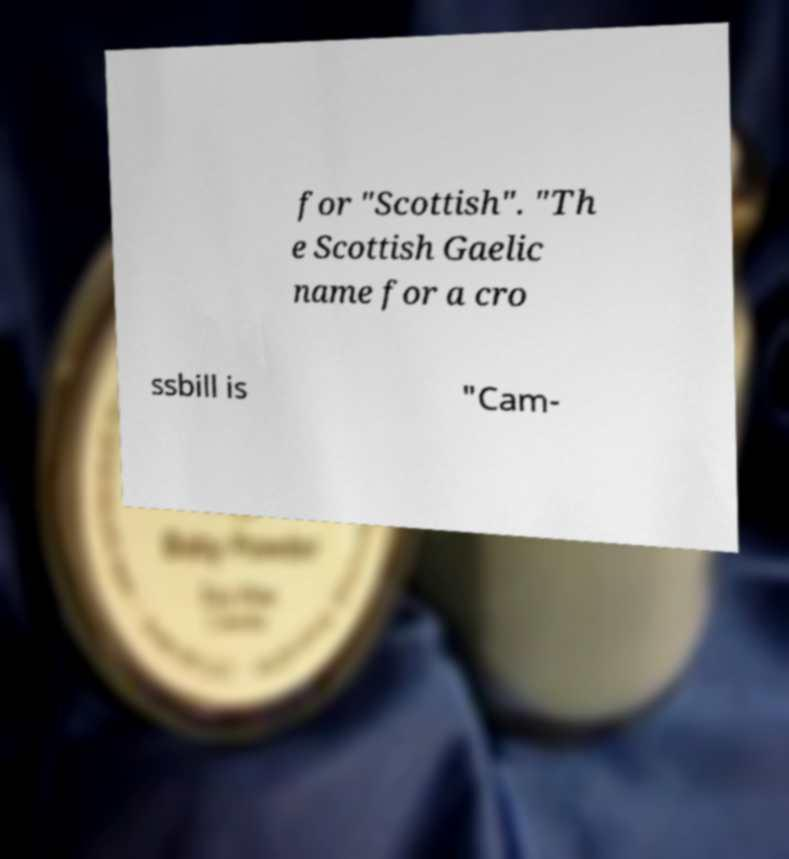Could you assist in decoding the text presented in this image and type it out clearly? for "Scottish". "Th e Scottish Gaelic name for a cro ssbill is "Cam- 